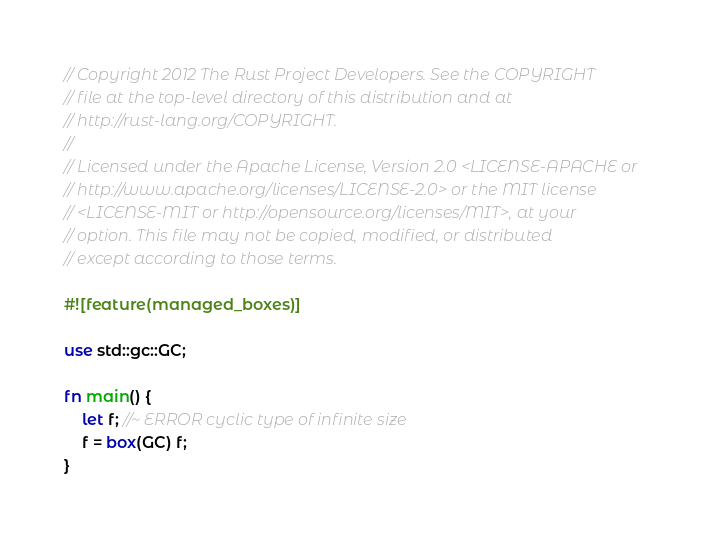<code> <loc_0><loc_0><loc_500><loc_500><_Rust_>// Copyright 2012 The Rust Project Developers. See the COPYRIGHT
// file at the top-level directory of this distribution and at
// http://rust-lang.org/COPYRIGHT.
//
// Licensed under the Apache License, Version 2.0 <LICENSE-APACHE or
// http://www.apache.org/licenses/LICENSE-2.0> or the MIT license
// <LICENSE-MIT or http://opensource.org/licenses/MIT>, at your
// option. This file may not be copied, modified, or distributed
// except according to those terms.

#![feature(managed_boxes)]

use std::gc::GC;

fn main() {
    let f; //~ ERROR cyclic type of infinite size
    f = box(GC) f;
}
</code> 